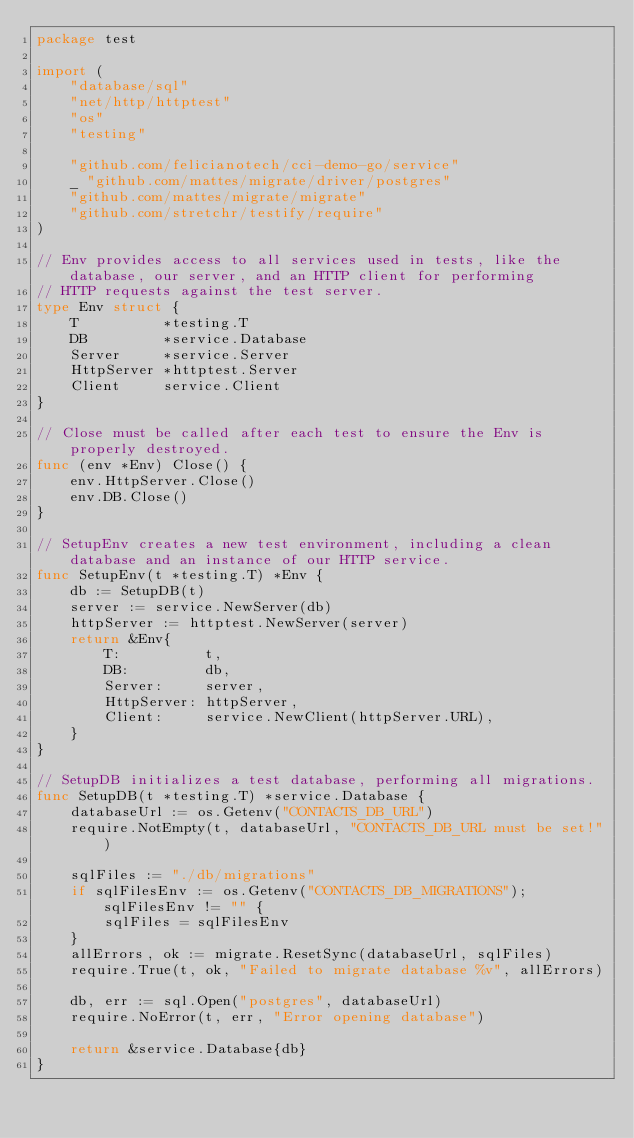<code> <loc_0><loc_0><loc_500><loc_500><_Go_>package test

import (
	"database/sql"
	"net/http/httptest"
	"os"
	"testing"

	"github.com/felicianotech/cci-demo-go/service"
	_ "github.com/mattes/migrate/driver/postgres"
	"github.com/mattes/migrate/migrate"
	"github.com/stretchr/testify/require"
)

// Env provides access to all services used in tests, like the database, our server, and an HTTP client for performing
// HTTP requests against the test server.
type Env struct {
	T          *testing.T
	DB         *service.Database
	Server     *service.Server
	HttpServer *httptest.Server
	Client     service.Client
}

// Close must be called after each test to ensure the Env is properly destroyed.
func (env *Env) Close() {
	env.HttpServer.Close()
	env.DB.Close()
}

// SetupEnv creates a new test environment, including a clean database and an instance of our HTTP service.
func SetupEnv(t *testing.T) *Env {
	db := SetupDB(t)
	server := service.NewServer(db)
	httpServer := httptest.NewServer(server)
	return &Env{
		T:          t,
		DB:         db,
		Server:     server,
		HttpServer: httpServer,
		Client:     service.NewClient(httpServer.URL),
	}
}

// SetupDB initializes a test database, performing all migrations.
func SetupDB(t *testing.T) *service.Database {
	databaseUrl := os.Getenv("CONTACTS_DB_URL")
	require.NotEmpty(t, databaseUrl, "CONTACTS_DB_URL must be set!")

	sqlFiles := "./db/migrations"
	if sqlFilesEnv := os.Getenv("CONTACTS_DB_MIGRATIONS"); sqlFilesEnv != "" {
		sqlFiles = sqlFilesEnv
	}
	allErrors, ok := migrate.ResetSync(databaseUrl, sqlFiles)
	require.True(t, ok, "Failed to migrate database %v", allErrors)

	db, err := sql.Open("postgres", databaseUrl)
	require.NoError(t, err, "Error opening database")

	return &service.Database{db}
}
</code> 